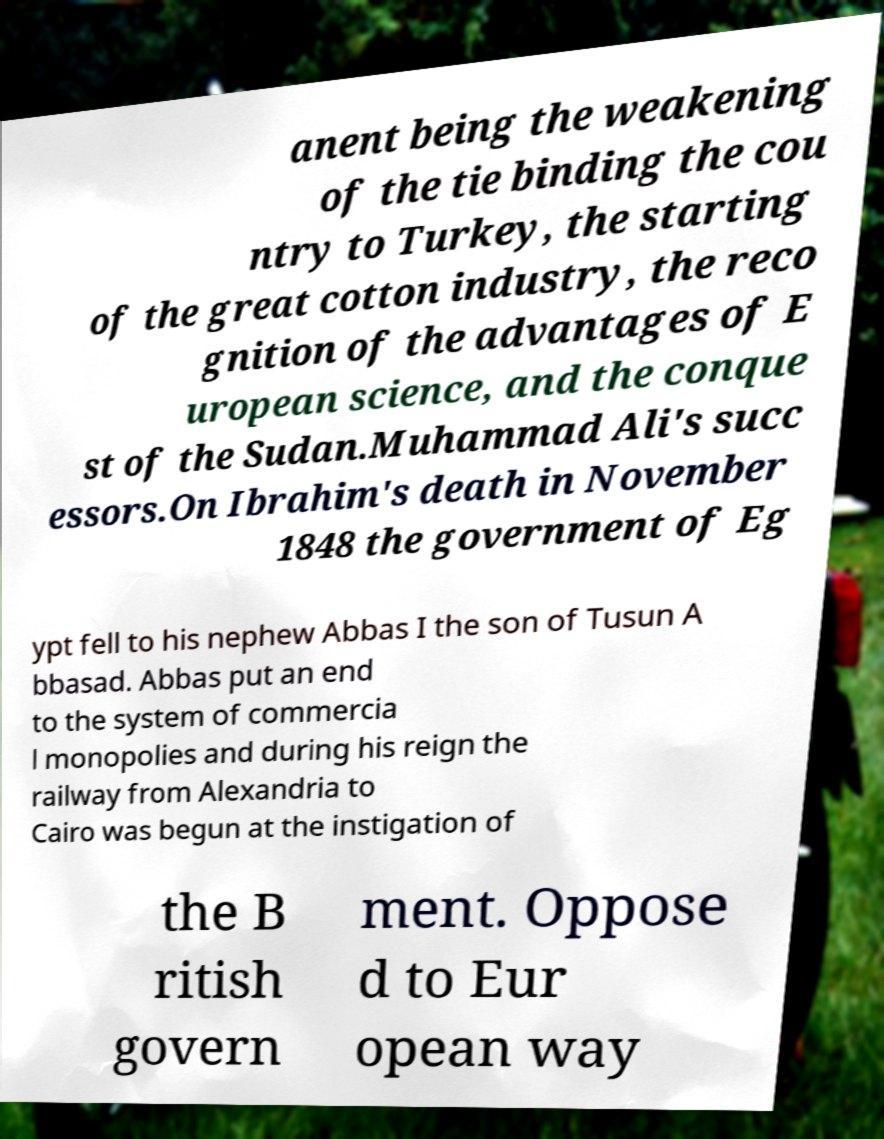There's text embedded in this image that I need extracted. Can you transcribe it verbatim? anent being the weakening of the tie binding the cou ntry to Turkey, the starting of the great cotton industry, the reco gnition of the advantages of E uropean science, and the conque st of the Sudan.Muhammad Ali's succ essors.On Ibrahim's death in November 1848 the government of Eg ypt fell to his nephew Abbas I the son of Tusun A bbasad. Abbas put an end to the system of commercia l monopolies and during his reign the railway from Alexandria to Cairo was begun at the instigation of the B ritish govern ment. Oppose d to Eur opean way 